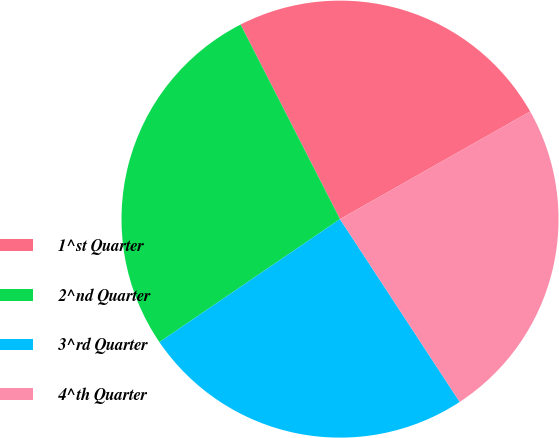Convert chart. <chart><loc_0><loc_0><loc_500><loc_500><pie_chart><fcel>1^st Quarter<fcel>2^nd Quarter<fcel>3^rd Quarter<fcel>4^th Quarter<nl><fcel>24.32%<fcel>27.0%<fcel>24.71%<fcel>23.97%<nl></chart> 